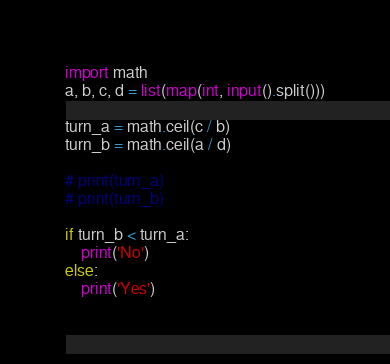<code> <loc_0><loc_0><loc_500><loc_500><_Python_>import math
a, b, c, d = list(map(int, input().split()))

turn_a = math.ceil(c / b)
turn_b = math.ceil(a / d)

# print(turn_a)
# print(turn_b)

if turn_b < turn_a:
    print('No')
else:
    print('Yes')
</code> 